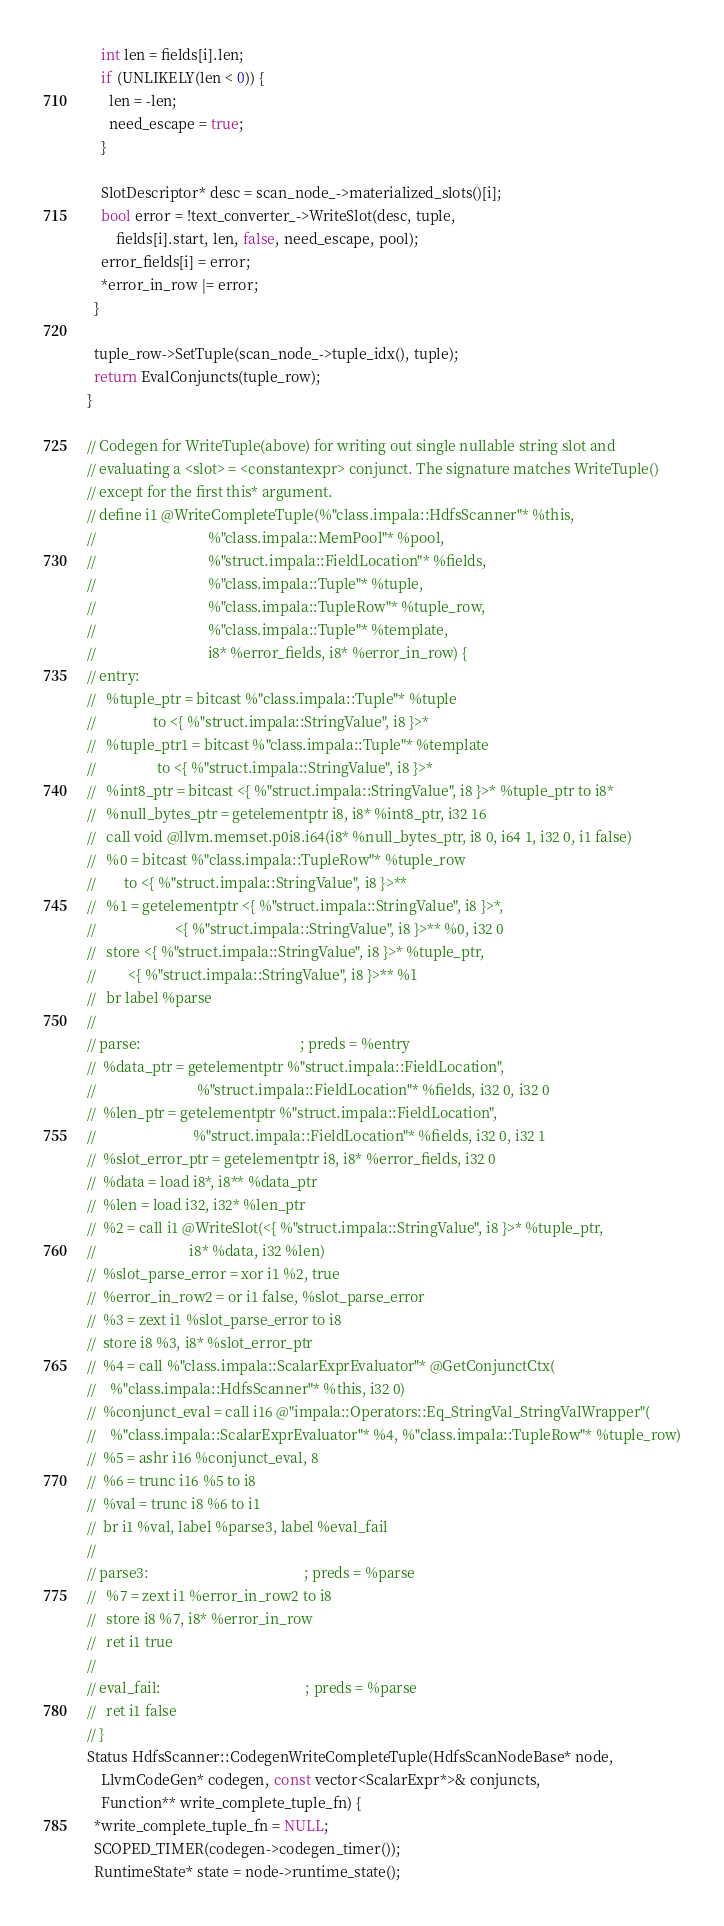<code> <loc_0><loc_0><loc_500><loc_500><_C++_>    int len = fields[i].len;
    if (UNLIKELY(len < 0)) {
      len = -len;
      need_escape = true;
    }

    SlotDescriptor* desc = scan_node_->materialized_slots()[i];
    bool error = !text_converter_->WriteSlot(desc, tuple,
        fields[i].start, len, false, need_escape, pool);
    error_fields[i] = error;
    *error_in_row |= error;
  }

  tuple_row->SetTuple(scan_node_->tuple_idx(), tuple);
  return EvalConjuncts(tuple_row);
}

// Codegen for WriteTuple(above) for writing out single nullable string slot and
// evaluating a <slot> = <constantexpr> conjunct. The signature matches WriteTuple()
// except for the first this* argument.
// define i1 @WriteCompleteTuple(%"class.impala::HdfsScanner"* %this,
//                               %"class.impala::MemPool"* %pool,
//                               %"struct.impala::FieldLocation"* %fields,
//                               %"class.impala::Tuple"* %tuple,
//                               %"class.impala::TupleRow"* %tuple_row,
//                               %"class.impala::Tuple"* %template,
//                               i8* %error_fields, i8* %error_in_row) {
// entry:
//   %tuple_ptr = bitcast %"class.impala::Tuple"* %tuple
//                to <{ %"struct.impala::StringValue", i8 }>*
//   %tuple_ptr1 = bitcast %"class.impala::Tuple"* %template
//                 to <{ %"struct.impala::StringValue", i8 }>*
//   %int8_ptr = bitcast <{ %"struct.impala::StringValue", i8 }>* %tuple_ptr to i8*
//   %null_bytes_ptr = getelementptr i8, i8* %int8_ptr, i32 16
//   call void @llvm.memset.p0i8.i64(i8* %null_bytes_ptr, i8 0, i64 1, i32 0, i1 false)
//   %0 = bitcast %"class.impala::TupleRow"* %tuple_row
//        to <{ %"struct.impala::StringValue", i8 }>**
//   %1 = getelementptr <{ %"struct.impala::StringValue", i8 }>*,
//                      <{ %"struct.impala::StringValue", i8 }>** %0, i32 0
//   store <{ %"struct.impala::StringValue", i8 }>* %tuple_ptr,
//         <{ %"struct.impala::StringValue", i8 }>** %1
//   br label %parse
//
// parse:                                            ; preds = %entry
//  %data_ptr = getelementptr %"struct.impala::FieldLocation",
//                            %"struct.impala::FieldLocation"* %fields, i32 0, i32 0
//  %len_ptr = getelementptr %"struct.impala::FieldLocation",
//                           %"struct.impala::FieldLocation"* %fields, i32 0, i32 1
//  %slot_error_ptr = getelementptr i8, i8* %error_fields, i32 0
//  %data = load i8*, i8** %data_ptr
//  %len = load i32, i32* %len_ptr
//  %2 = call i1 @WriteSlot(<{ %"struct.impala::StringValue", i8 }>* %tuple_ptr,
//                          i8* %data, i32 %len)
//  %slot_parse_error = xor i1 %2, true
//  %error_in_row2 = or i1 false, %slot_parse_error
//  %3 = zext i1 %slot_parse_error to i8
//  store i8 %3, i8* %slot_error_ptr
//  %4 = call %"class.impala::ScalarExprEvaluator"* @GetConjunctCtx(
//    %"class.impala::HdfsScanner"* %this, i32 0)
//  %conjunct_eval = call i16 @"impala::Operators::Eq_StringVal_StringValWrapper"(
//    %"class.impala::ScalarExprEvaluator"* %4, %"class.impala::TupleRow"* %tuple_row)
//  %5 = ashr i16 %conjunct_eval, 8
//  %6 = trunc i16 %5 to i8
//  %val = trunc i8 %6 to i1
//  br i1 %val, label %parse3, label %eval_fail
//
// parse3:                                           ; preds = %parse
//   %7 = zext i1 %error_in_row2 to i8
//   store i8 %7, i8* %error_in_row
//   ret i1 true
//
// eval_fail:                                        ; preds = %parse
//   ret i1 false
// }
Status HdfsScanner::CodegenWriteCompleteTuple(HdfsScanNodeBase* node,
    LlvmCodeGen* codegen, const vector<ScalarExpr*>& conjuncts,
    Function** write_complete_tuple_fn) {
  *write_complete_tuple_fn = NULL;
  SCOPED_TIMER(codegen->codegen_timer());
  RuntimeState* state = node->runtime_state();
</code> 